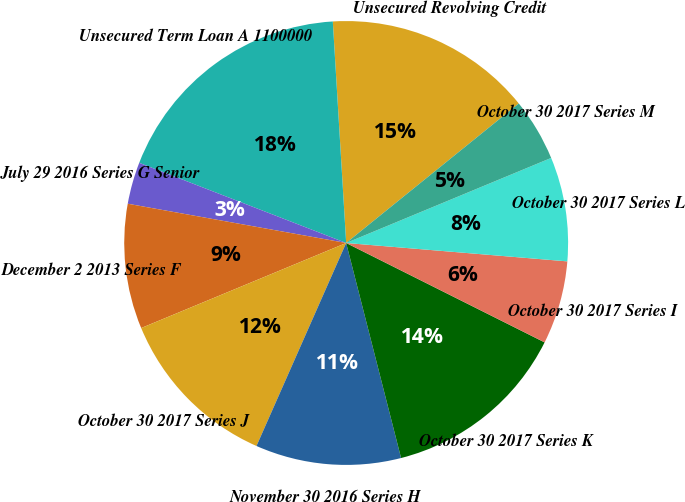<chart> <loc_0><loc_0><loc_500><loc_500><pie_chart><fcel>Unsecured Revolving Credit<fcel>Unsecured Term Loan A 1100000<fcel>July 29 2016 Series G Senior<fcel>December 2 2013 Series F<fcel>October 30 2017 Series J<fcel>November 30 2016 Series H<fcel>October 30 2017 Series K<fcel>October 30 2017 Series I<fcel>October 30 2017 Series L<fcel>October 30 2017 Series M<nl><fcel>15.14%<fcel>18.16%<fcel>3.05%<fcel>9.09%<fcel>12.12%<fcel>10.6%<fcel>13.63%<fcel>6.07%<fcel>7.58%<fcel>4.56%<nl></chart> 